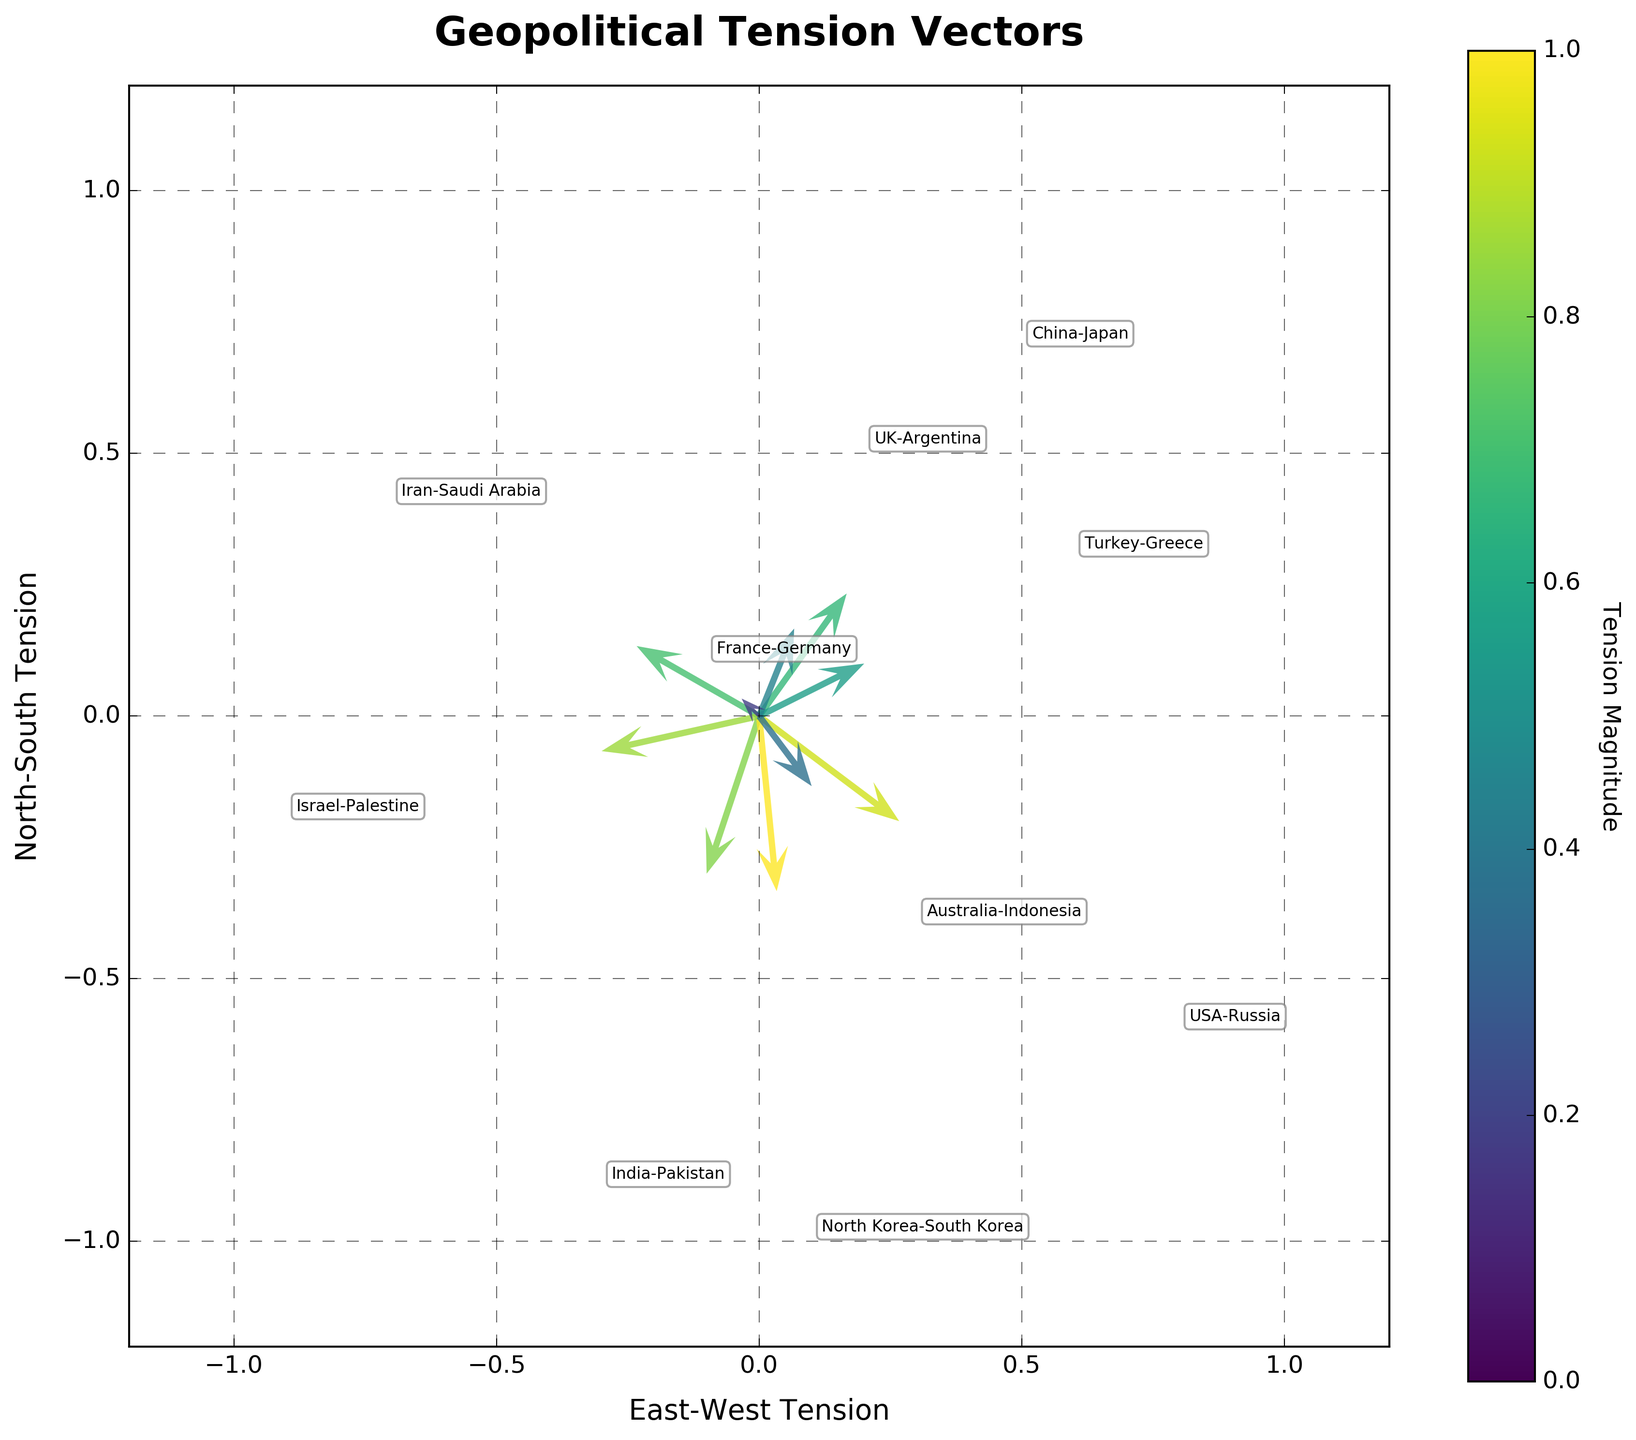What's the title of the figure? The title of the figure is displayed at the top of the plot, which specifies what the figure represents.
Answer: Geopolitical Tension Vectors How many tension vectors are represented in the plot? Each vector represents a pair of countries; counting the number of pairs illustrated in the plot gives the total number of tension vectors.
Answer: 10 Which pair of countries has the highest tension magnitude? The color bar on the plot indicates the tension magnitude. The country pair corresponding to the darkest shade (closest to max) on the scale represents the highest tension magnitude.
Answer: North Korea-South Korea What are the labels on the axes? The labels on the axes describe the type of tension measured on each axis.
Answer: East-West Tension, North-South Tension Which country pair represents an East-West tension of -0.7 and a North-South tension of 0.4? Locate the vector with the specified coordinates on the plot and find its corresponding annotation.
Answer: Iran-Saudi Arabia Compare the directions of tension vectors between USA-Russia and China-Japan. Observe the direction in which the arrows for both pairs point by looking at their East-West and North-South tensions.
Answer: USA-Russia points southwest, China-Japan points northeast Which country pair has the smallest tension magnitude? By examining the color gradient in the plot and referencing the lightest shade on the scale.
Answer: France-Germany What is the general direction of the tension vector for Israel-Palestine? By checking the coordinates associated with the Israel-Palestine annotation on the plot, you can infer the primary direction.
Answer: Southwest Identify the vector associated with Turkey-Greece. What is its direction relative to the origin? Find the annotated vector for Turkey-Greece and assess its direction by evaluating its tension coordinates.
Answer: Northwest Compare the magnitude of tension between India-Pakistan and USA-Russia. Refer to the color intensity of both vectors, as well as the magnitudes given in the data, and compare.
Answer: USA-Russia has a higher tension magnitude 